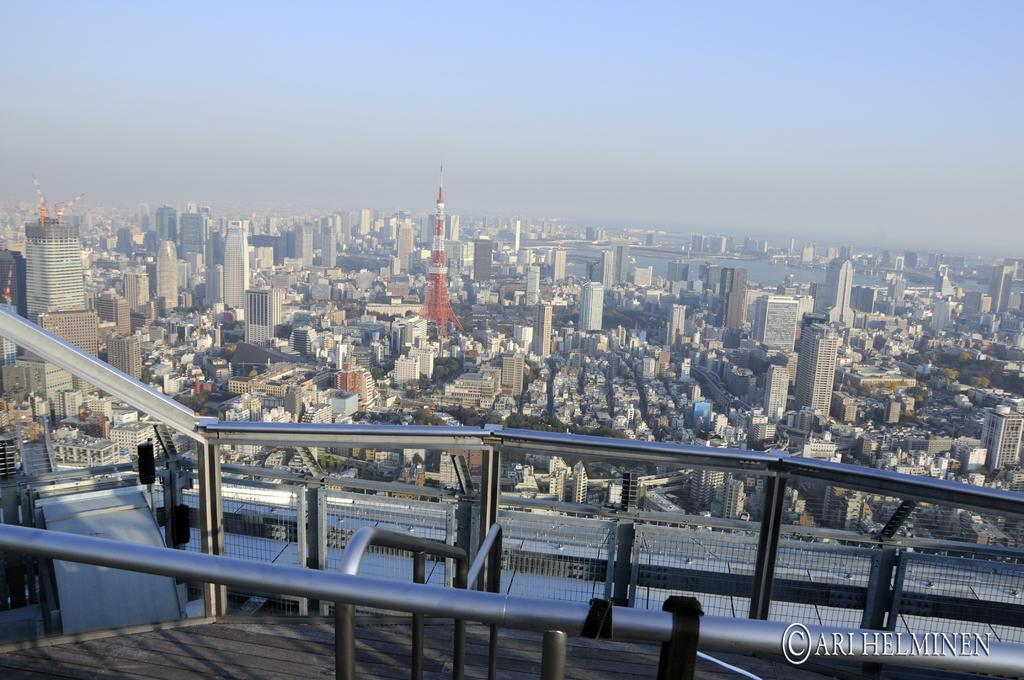What type of view is shown in the image? The image is a top view of a city. What is located in front of the image? There is a metal rod fence in front of the image. What information can be found at the bottom of the image? There is some text at the bottom of the image. What structures are visible in the image? There are buildings in the image. What natural feature is present in the image? There is a river in the image. What color is the shirt worn by the person with a stomach ache in the image? There are no people or stomach aches present in the image; it is a top view of a city with buildings, a river, and a metal rod fence. 